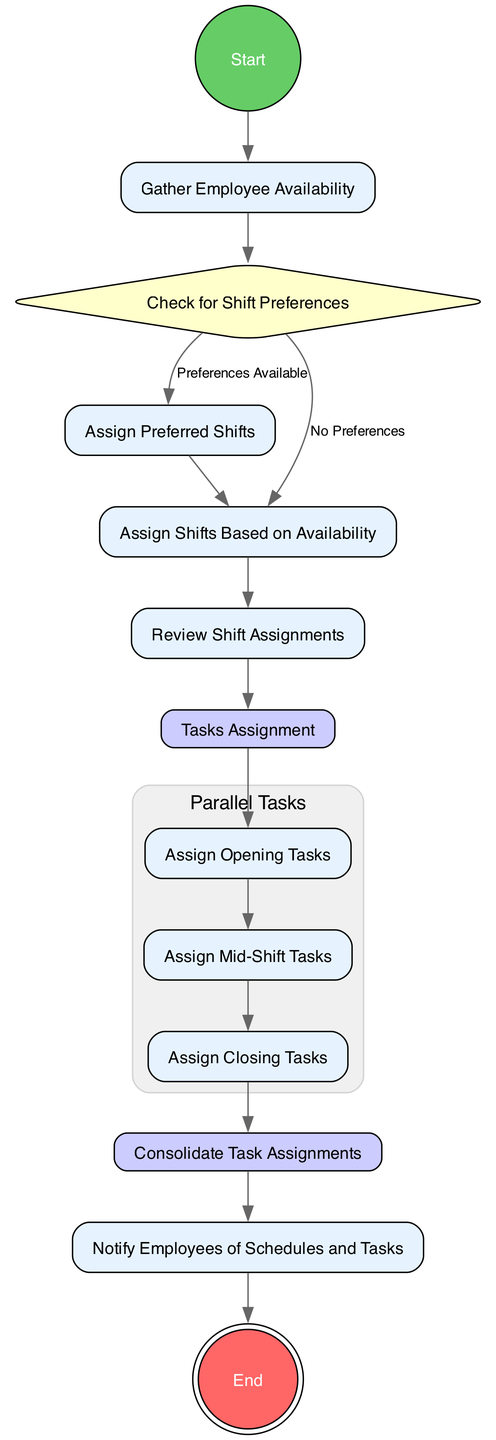What's the starting point of the activity diagram? The starting point is an "InitialNode," which is labeled as "Start." It indicates where the flow begins in the activity diagram.
Answer: Start How many action nodes are present in the diagram? The action nodes in the diagram include "Gather Employee Availability," "Assign Preferred Shifts," "Assign Shifts Based on Availability," "Review Shift Assignments," "Assign Opening Tasks," "Assign Mid-Shift Tasks," "Assign Closing Tasks," and "Notify Employees of Schedules and Tasks," totaling eight action nodes.
Answer: Eight What happens if preferences are not available? If "No Preferences" are indicated in the "Check for Shift Preferences," the diagram redirects to the "Assign Shifts Based on Availability" node, showing that shifts will be assigned based on what employees are available.
Answer: Assign Shifts Based on Availability What is the final action that occurs in the activity diagram? The final action, as depicted by the "FinalNode," is "End," signaling the completion of all scheduled tasks and notifications.
Answer: End Which node follows the "Tasks Assignment" node? After the "Tasks Assignment" node, three parallel tasks are assigned, specifically "Assign Opening Tasks," "Assign Mid-Shift Tasks," and "Assign Closing Tasks," which follow the fork action branching out.
Answer: Assign Opening Tasks, Assign Mid-Shift Tasks, Assign Closing Tasks How does the flow proceed after the "Review Shift Assignments"? Post "Review Shift Assignments," the next step branches into "Tasks Assignment," which then splits into several task assignments, demonstrating that after assignments are reviewed, tasks are then allocated in a parallel manner.
Answer: Tasks Assignment What type of node is "Check for Shift Preferences"? The "Check for Shift Preferences" is classified as a "DecisionNode," which contains conditions that lead to different pathways in the diagram based on the presence of shift preferences.
Answer: DecisionNode What does the "Consolidate Task Assignments" node represent? The "Consolidate Task Assignments" is a "JoinNode," indicating that all task-related actions converge here before moving on to notify the employees. It signifies the completion and integration of all assigned tasks.
Answer: JoinNode What will be the outcome if employee preferences are present? If "Preferences Available" are indicated, the flow will lead to "Assign Preferred Shifts," suggesting that the system prioritizes employee preferences when assigning shifts.
Answer: Assign Preferred Shifts 